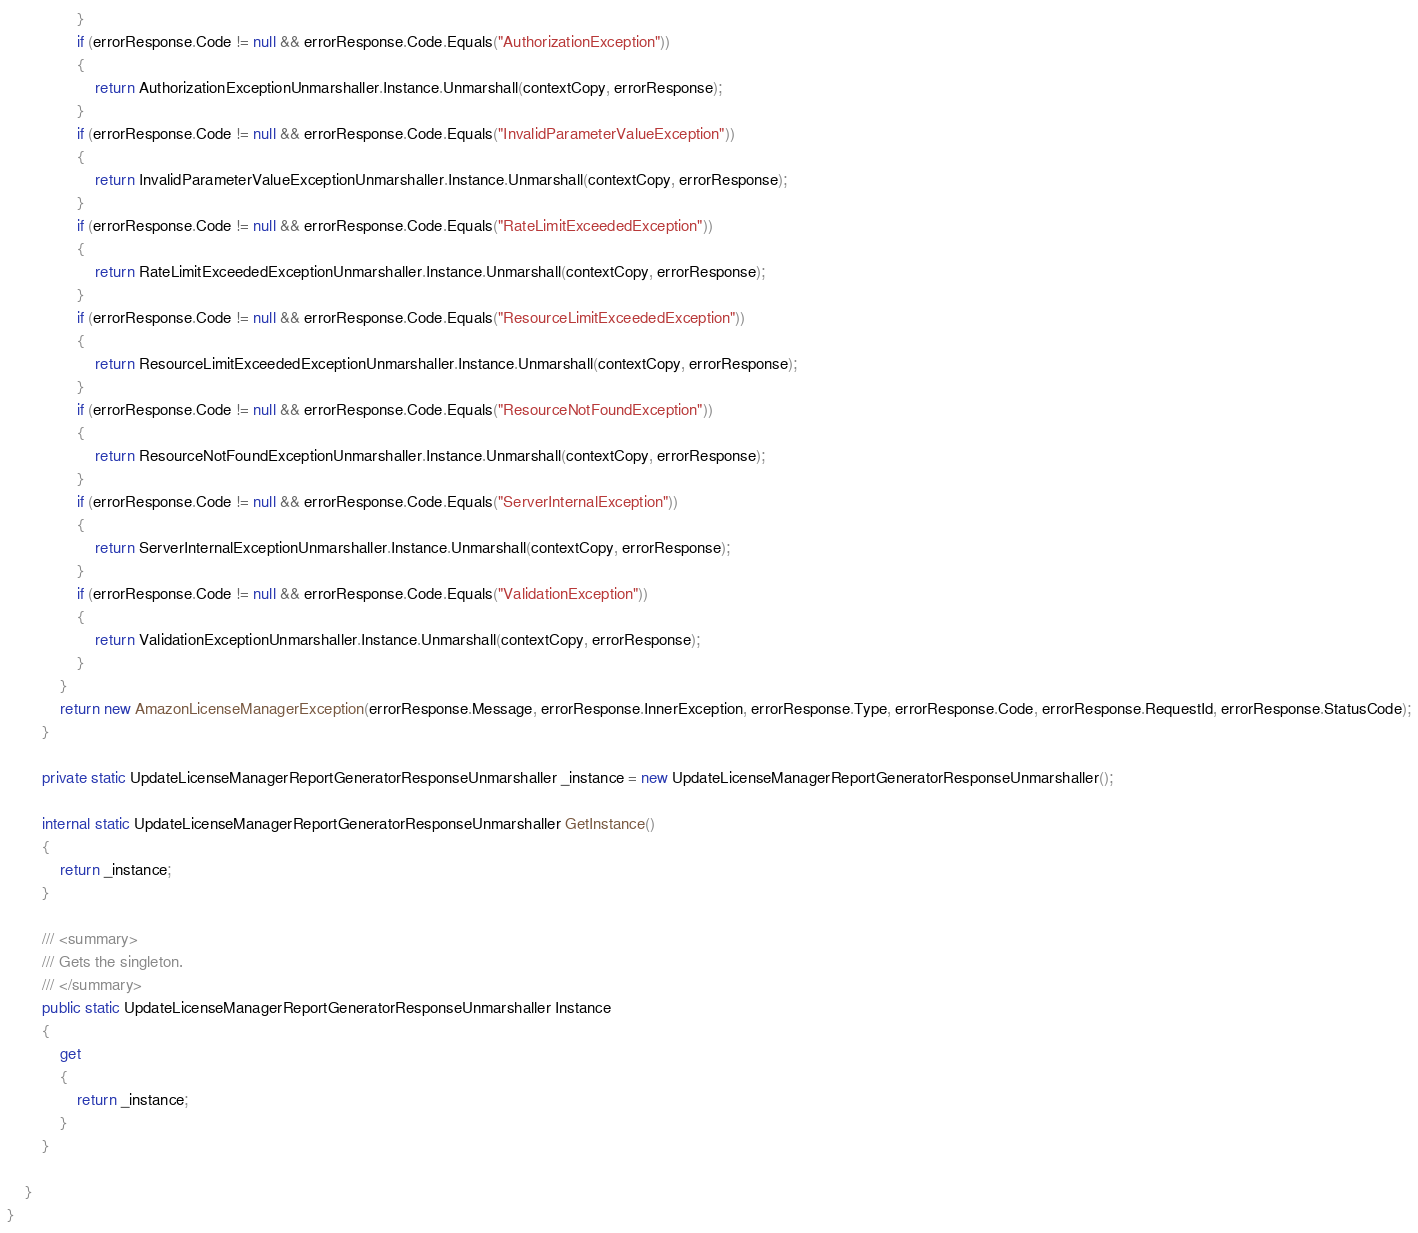<code> <loc_0><loc_0><loc_500><loc_500><_C#_>                }
                if (errorResponse.Code != null && errorResponse.Code.Equals("AuthorizationException"))
                {
                    return AuthorizationExceptionUnmarshaller.Instance.Unmarshall(contextCopy, errorResponse);
                }
                if (errorResponse.Code != null && errorResponse.Code.Equals("InvalidParameterValueException"))
                {
                    return InvalidParameterValueExceptionUnmarshaller.Instance.Unmarshall(contextCopy, errorResponse);
                }
                if (errorResponse.Code != null && errorResponse.Code.Equals("RateLimitExceededException"))
                {
                    return RateLimitExceededExceptionUnmarshaller.Instance.Unmarshall(contextCopy, errorResponse);
                }
                if (errorResponse.Code != null && errorResponse.Code.Equals("ResourceLimitExceededException"))
                {
                    return ResourceLimitExceededExceptionUnmarshaller.Instance.Unmarshall(contextCopy, errorResponse);
                }
                if (errorResponse.Code != null && errorResponse.Code.Equals("ResourceNotFoundException"))
                {
                    return ResourceNotFoundExceptionUnmarshaller.Instance.Unmarshall(contextCopy, errorResponse);
                }
                if (errorResponse.Code != null && errorResponse.Code.Equals("ServerInternalException"))
                {
                    return ServerInternalExceptionUnmarshaller.Instance.Unmarshall(contextCopy, errorResponse);
                }
                if (errorResponse.Code != null && errorResponse.Code.Equals("ValidationException"))
                {
                    return ValidationExceptionUnmarshaller.Instance.Unmarshall(contextCopy, errorResponse);
                }
            }
            return new AmazonLicenseManagerException(errorResponse.Message, errorResponse.InnerException, errorResponse.Type, errorResponse.Code, errorResponse.RequestId, errorResponse.StatusCode);
        }

        private static UpdateLicenseManagerReportGeneratorResponseUnmarshaller _instance = new UpdateLicenseManagerReportGeneratorResponseUnmarshaller();        

        internal static UpdateLicenseManagerReportGeneratorResponseUnmarshaller GetInstance()
        {
            return _instance;
        }

        /// <summary>
        /// Gets the singleton.
        /// </summary>  
        public static UpdateLicenseManagerReportGeneratorResponseUnmarshaller Instance
        {
            get
            {
                return _instance;
            }
        }

    }
}</code> 